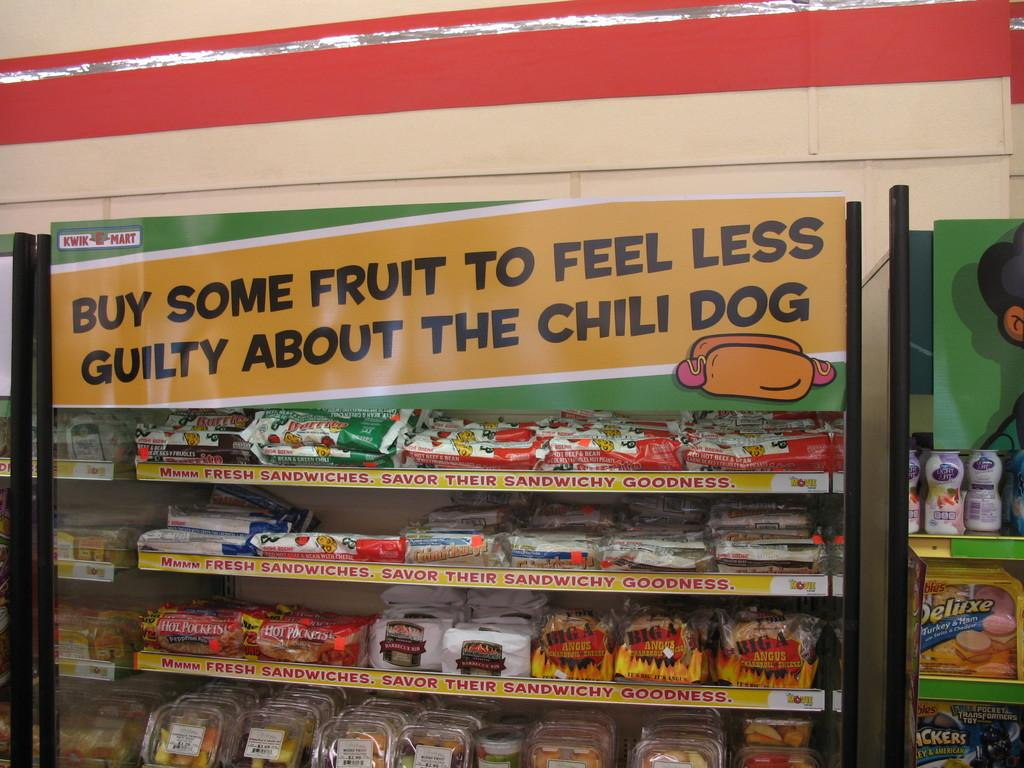<image>
Create a compact narrative representing the image presented. Freezer selling fresh sandwiches and many sandwichy goodness. 